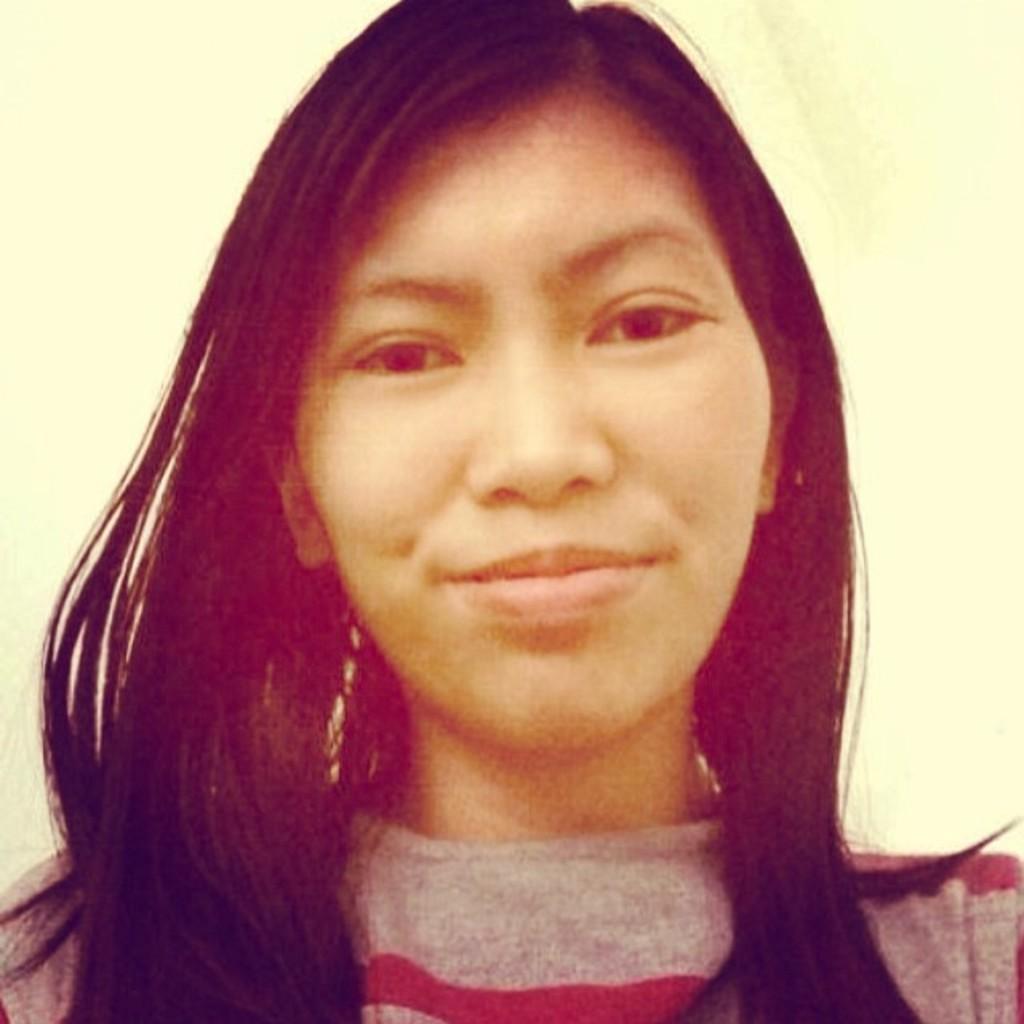Please provide a concise description of this image. In this picture we can see a woman smiling and in the background it is a cream color. 